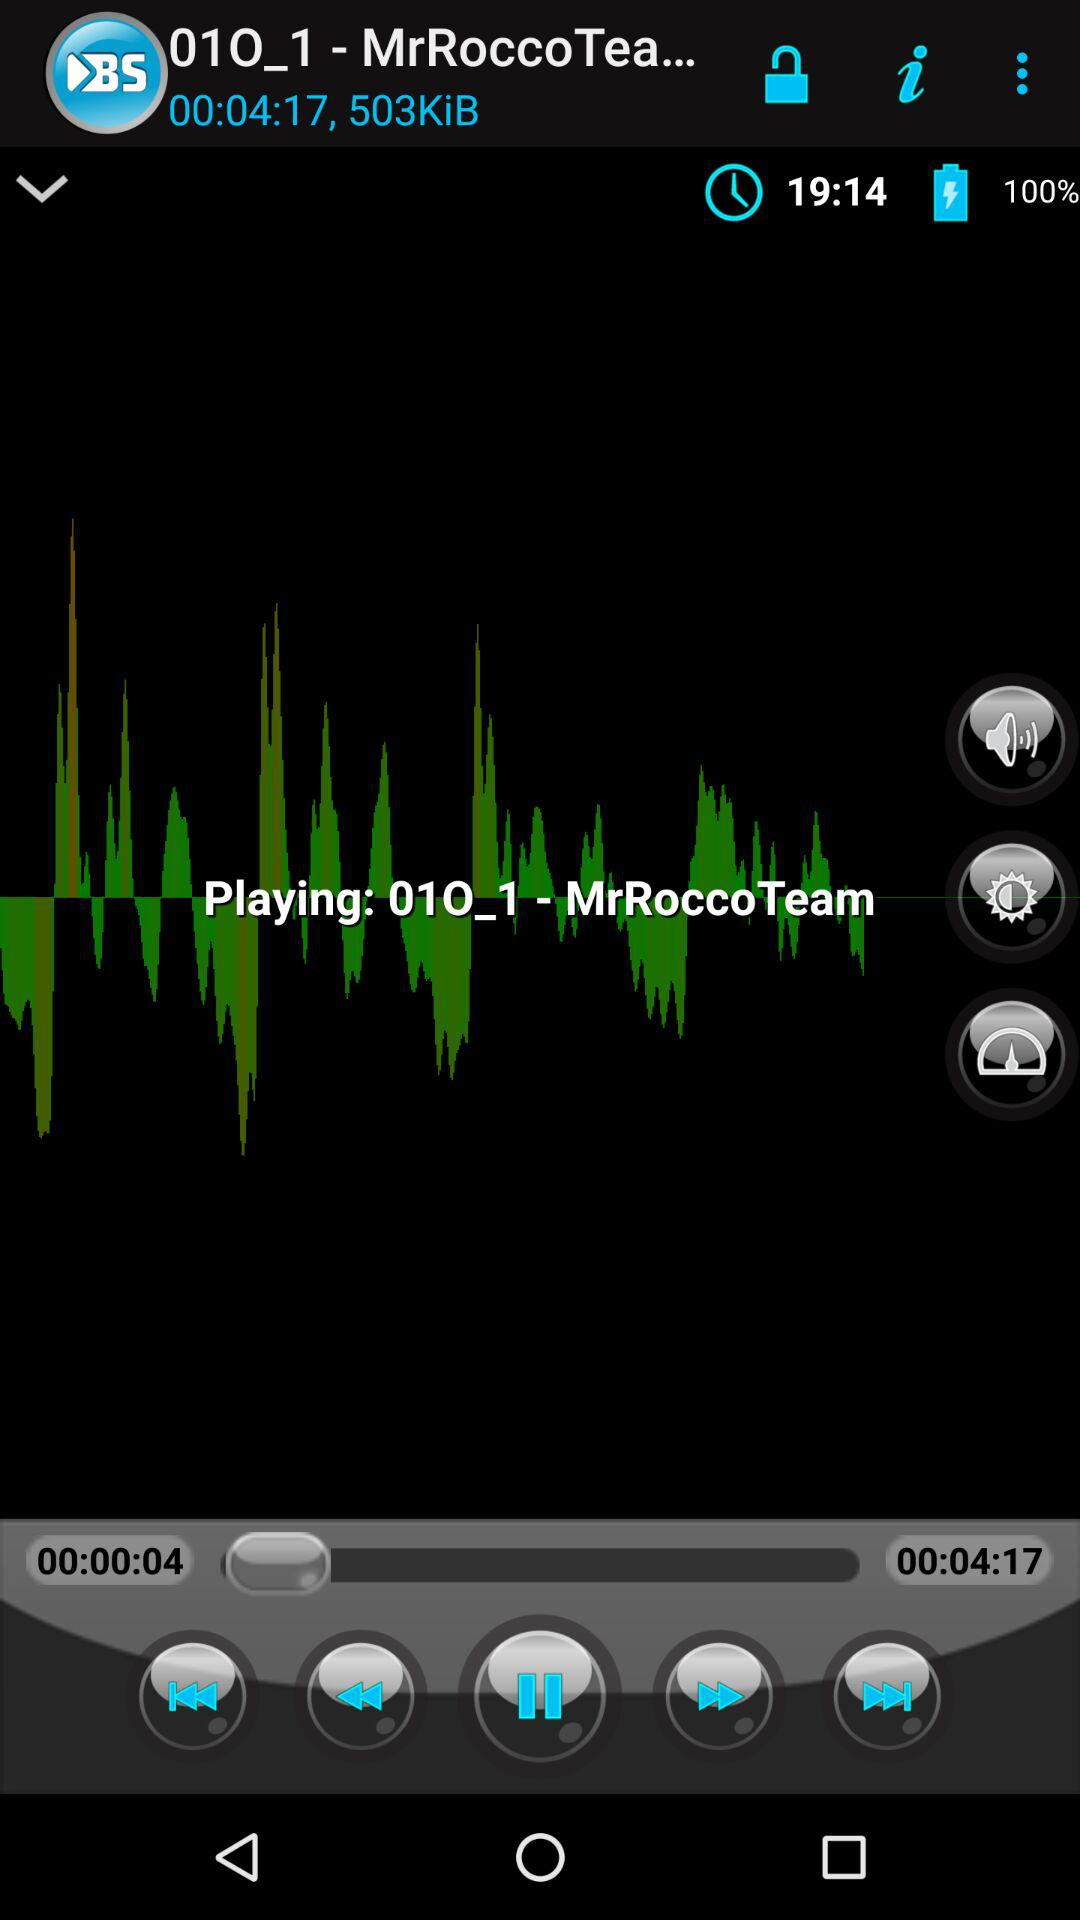What is the size of the song? The song is 503 KiB in size. 